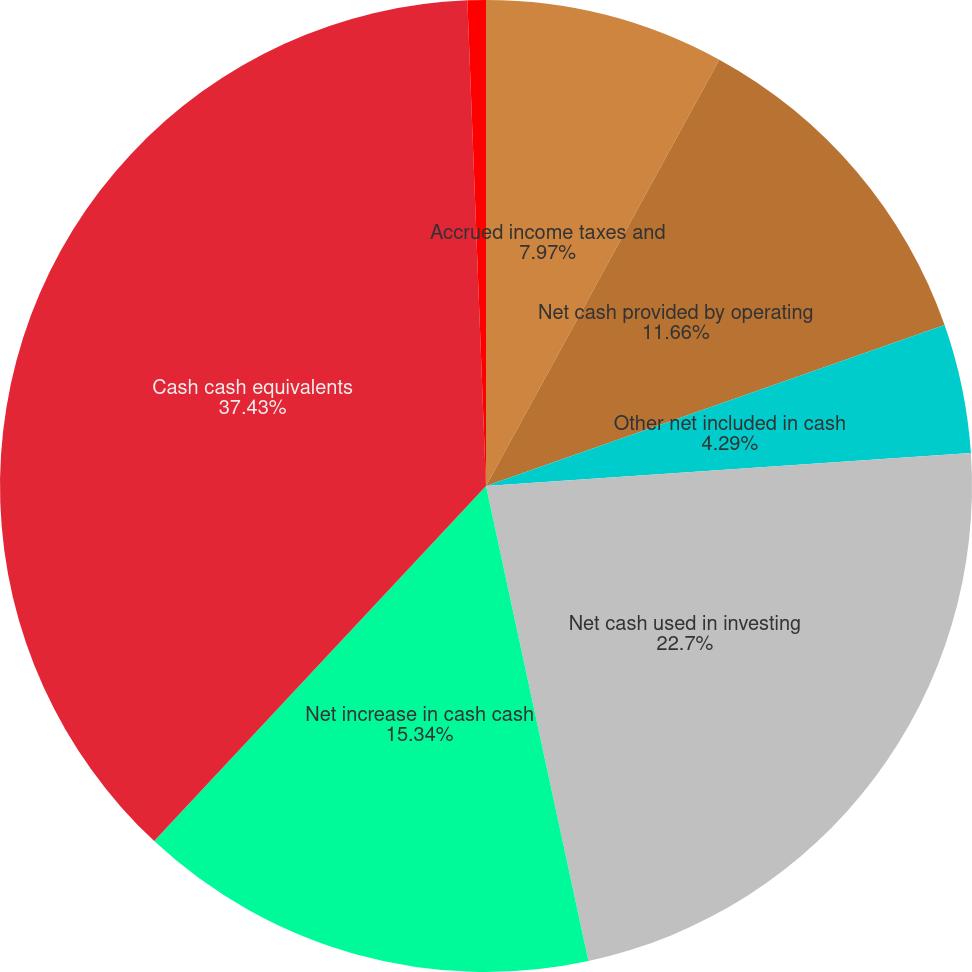Convert chart to OTSL. <chart><loc_0><loc_0><loc_500><loc_500><pie_chart><fcel>Accrued income taxes and<fcel>Net cash provided by operating<fcel>Other net included in cash<fcel>Net cash used in investing<fcel>Net increase in cash cash<fcel>Cash cash equivalents<fcel>Net cash provided by investing<nl><fcel>7.97%<fcel>11.66%<fcel>4.29%<fcel>22.7%<fcel>15.34%<fcel>37.43%<fcel>0.61%<nl></chart> 